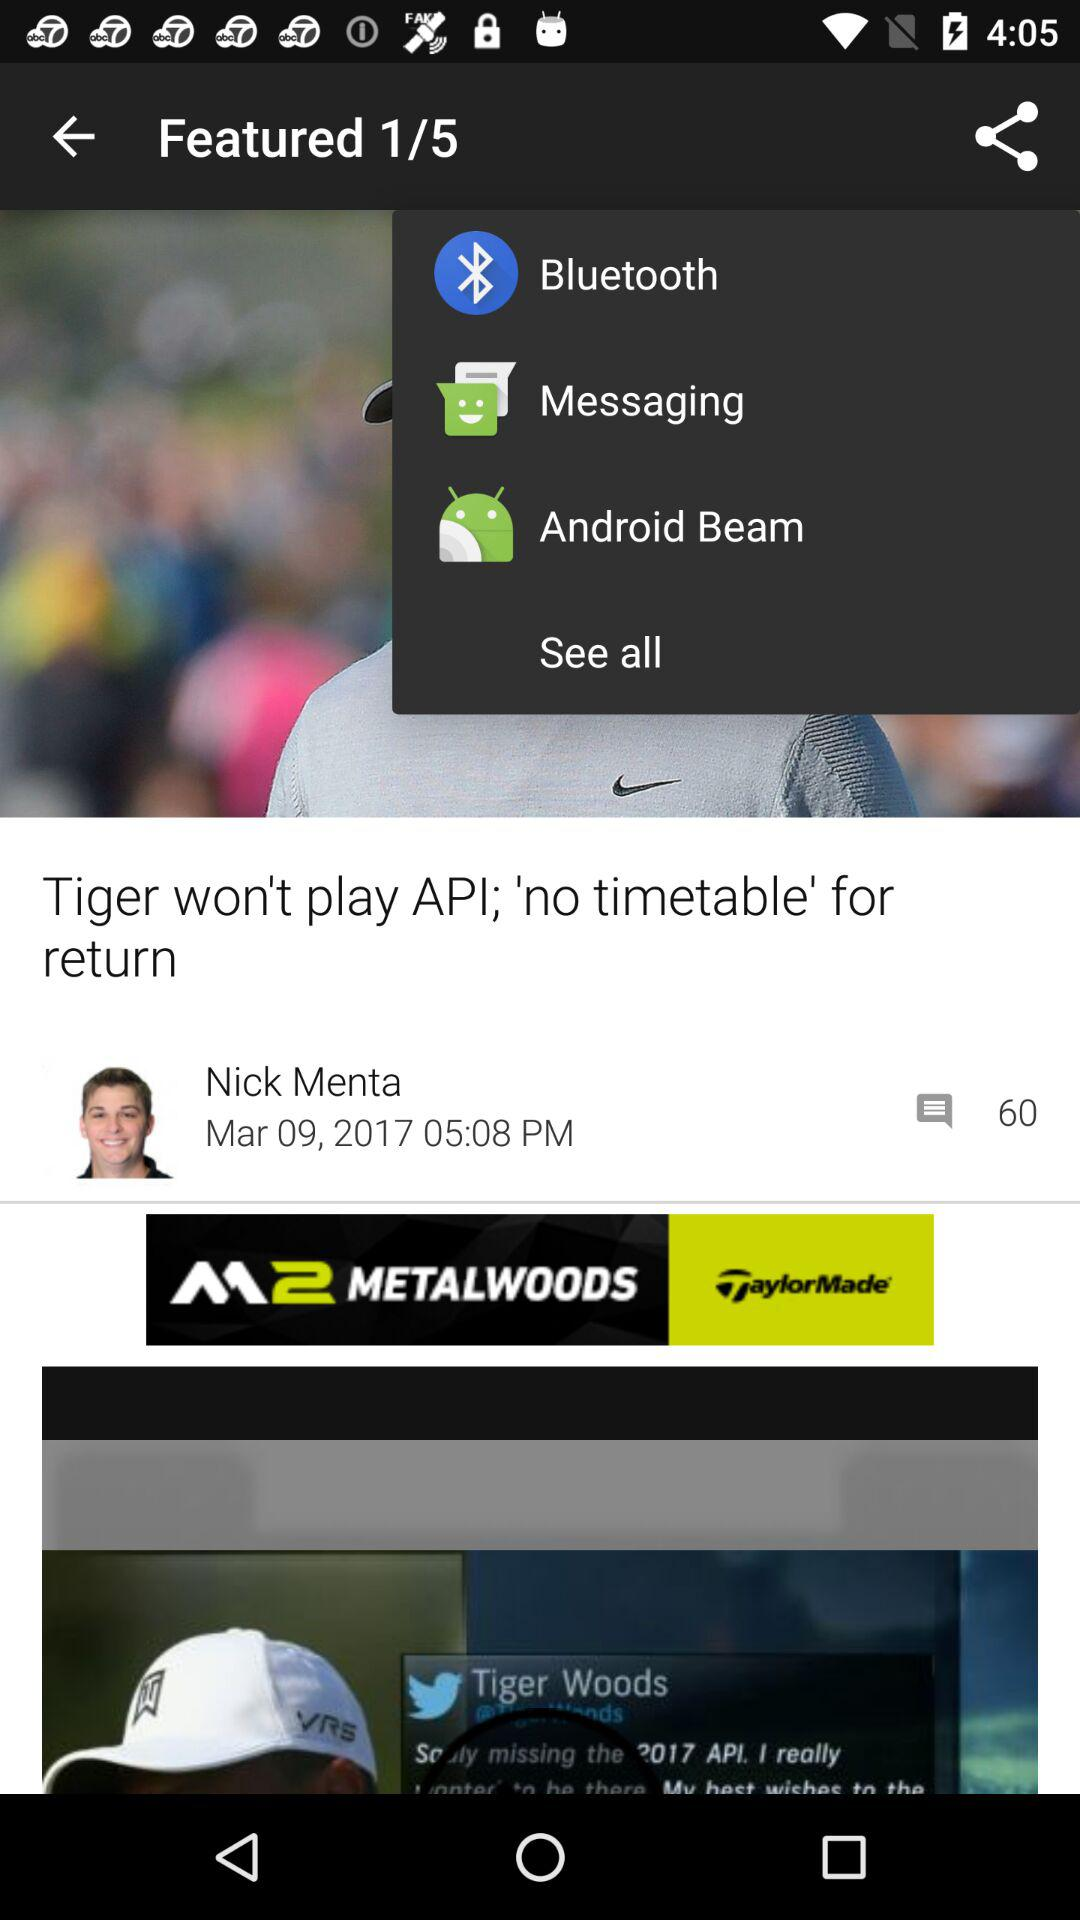What is the name of the user shown on the screen? The name of the user shown on the screen is Nick Menta. 